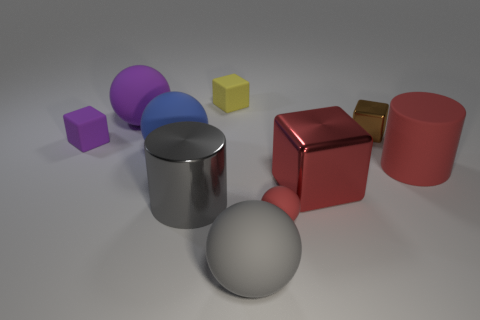Is the number of large gray matte objects to the left of the big purple object the same as the number of small brown metallic cubes that are on the left side of the big cube?
Offer a very short reply. Yes. What is the small sphere made of?
Keep it short and to the point. Rubber. There is a metallic cylinder that is the same size as the red metal thing; what color is it?
Ensure brevity in your answer.  Gray. There is a gray thing that is in front of the big metal cylinder; are there any brown blocks on the right side of it?
Your answer should be compact. Yes. What number of cylinders are large blue rubber things or large gray objects?
Offer a terse response. 1. What is the size of the red rubber thing that is to the left of the cylinder that is right of the large gray matte thing to the left of the tiny brown cube?
Provide a succinct answer. Small. There is a large gray sphere; are there any rubber cylinders behind it?
Make the answer very short. Yes. There is a small thing that is the same color as the matte cylinder; what shape is it?
Offer a terse response. Sphere. What number of things are small rubber objects that are to the right of the large metallic cylinder or tiny rubber balls?
Make the answer very short. 2. What is the size of the gray object that is made of the same material as the yellow block?
Provide a short and direct response. Large. 